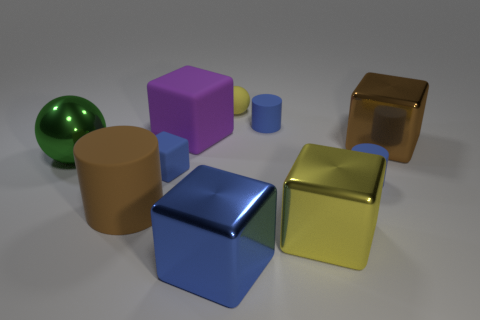Subtract all balls. How many objects are left? 8 Subtract 0 purple balls. How many objects are left? 10 Subtract all small balls. Subtract all brown rubber objects. How many objects are left? 8 Add 8 rubber balls. How many rubber balls are left? 9 Add 3 small matte things. How many small matte things exist? 7 